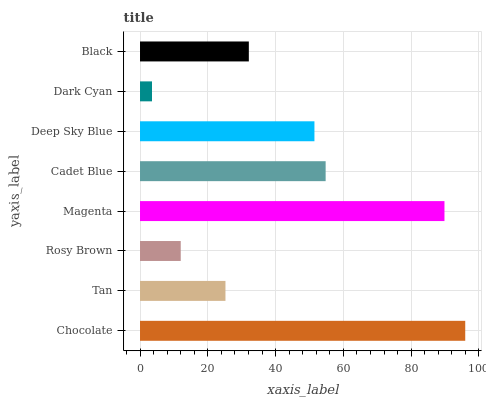Is Dark Cyan the minimum?
Answer yes or no. Yes. Is Chocolate the maximum?
Answer yes or no. Yes. Is Tan the minimum?
Answer yes or no. No. Is Tan the maximum?
Answer yes or no. No. Is Chocolate greater than Tan?
Answer yes or no. Yes. Is Tan less than Chocolate?
Answer yes or no. Yes. Is Tan greater than Chocolate?
Answer yes or no. No. Is Chocolate less than Tan?
Answer yes or no. No. Is Deep Sky Blue the high median?
Answer yes or no. Yes. Is Black the low median?
Answer yes or no. Yes. Is Magenta the high median?
Answer yes or no. No. Is Cadet Blue the low median?
Answer yes or no. No. 